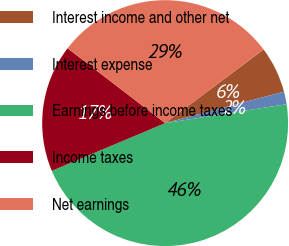Convert chart. <chart><loc_0><loc_0><loc_500><loc_500><pie_chart><fcel>Interest income and other net<fcel>Interest expense<fcel>Earnings before income taxes<fcel>Income taxes<fcel>Net earnings<nl><fcel>6.1%<fcel>1.66%<fcel>46.12%<fcel>16.75%<fcel>29.37%<nl></chart> 